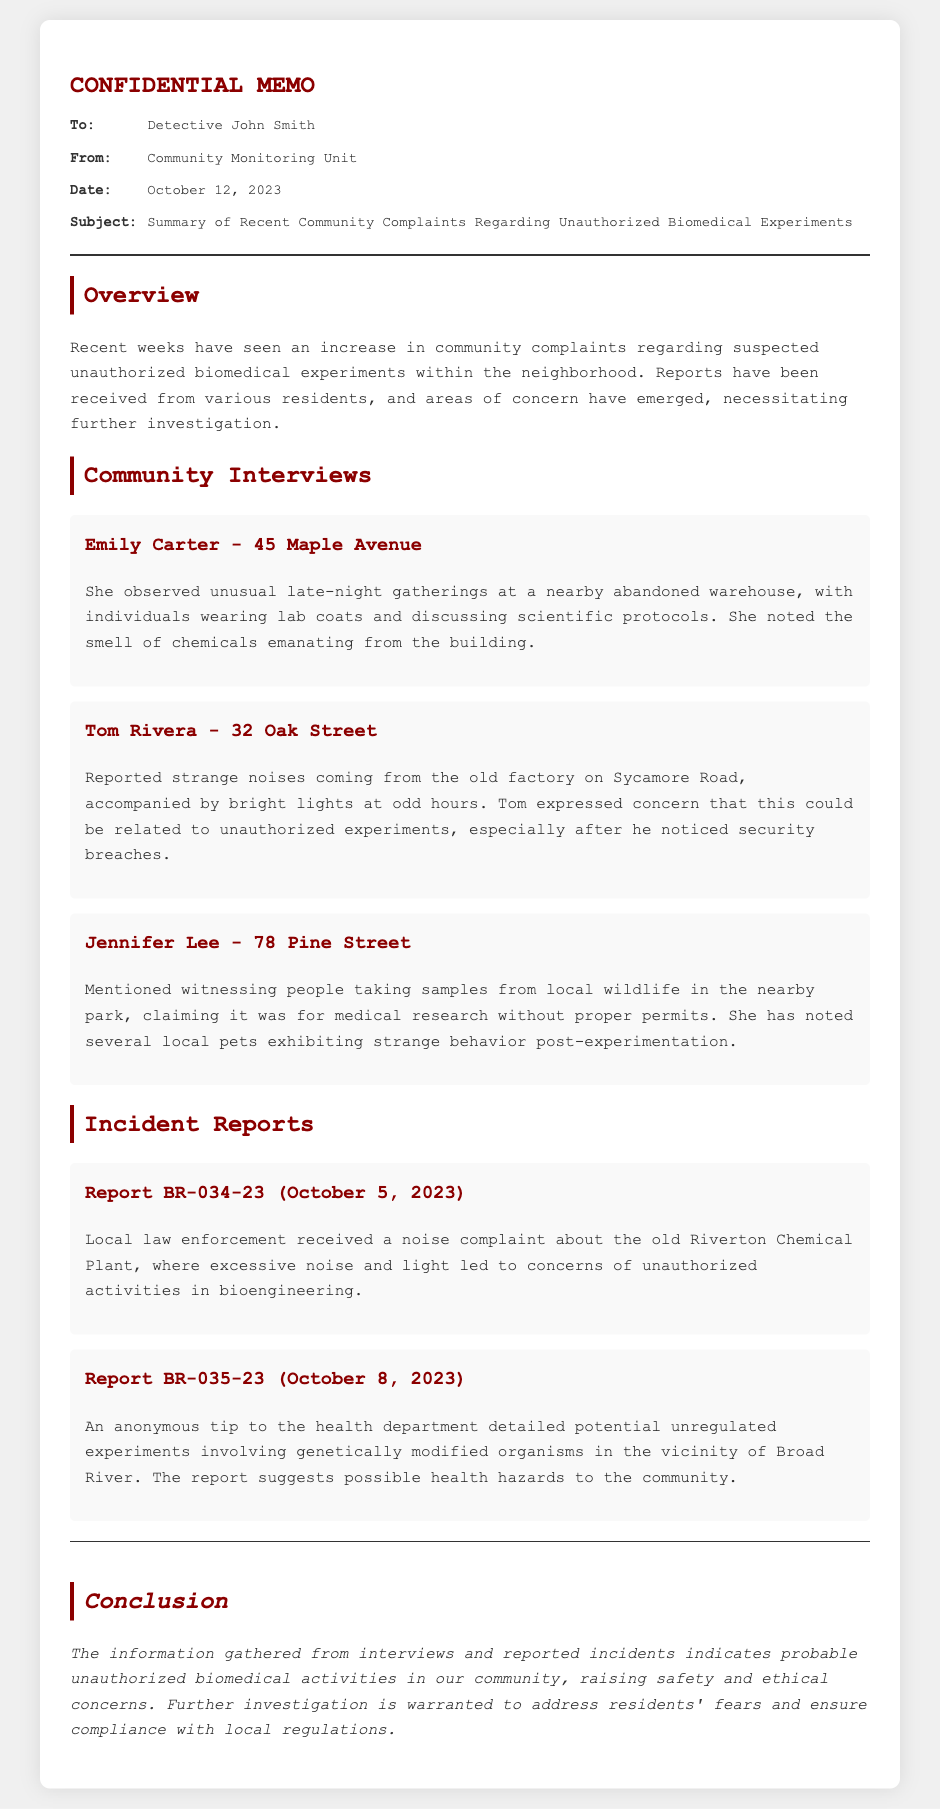What is the date of the memo? The date is provided in the meta section of the memo, stating when the memo was issued.
Answer: October 12, 2023 Who reported unusual gatherings at a warehouse? Emily Carter is the resident who described the late-night gatherings at the abandoned warehouse in her interview.
Answer: Emily Carter What was reported coming from the factory on Sycamore Road? The resident reported strange noises and bright lights, which raised concerns about unauthorized experiments.
Answer: Strange noises and bright lights What type of experiments are mentioned in the incident reports? The incident reports describe potential unauthorized biomedical activities, specifically mentioning genetically modified organisms.
Answer: Genetically modified organisms How many community interviews are noted in the memo? The memo includes accounts from three different residents who shared their observations and concerns about suspected activities.
Answer: Three 